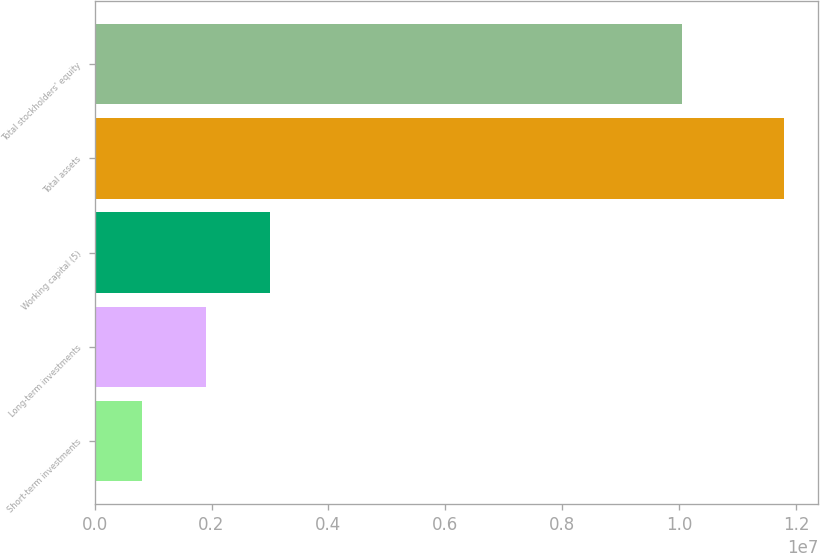<chart> <loc_0><loc_0><loc_500><loc_500><bar_chart><fcel>Short-term investments<fcel>Long-term investments<fcel>Working capital (5)<fcel>Total assets<fcel>Total stockholders' equity<nl><fcel>804352<fcel>1.90282e+06<fcel>3.00128e+06<fcel>1.1789e+07<fcel>1.0048e+07<nl></chart> 